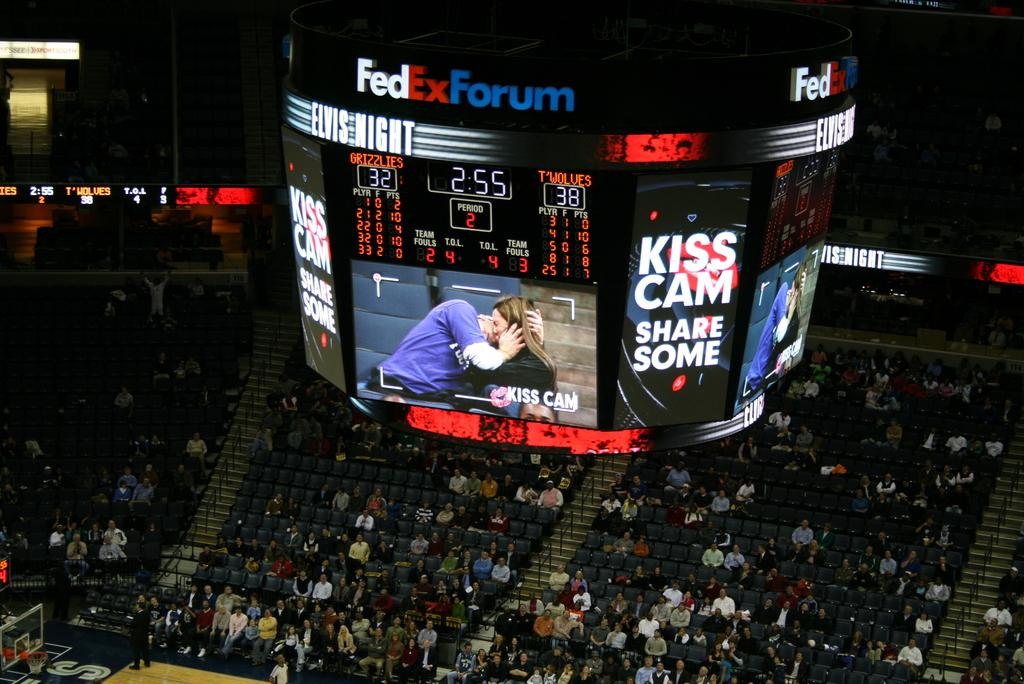<image>
Render a clear and concise summary of the photo. The scoreboard at FedEx Forum shows that the score is Minnesota Timberwolves 38, Memphis Grizzlies 32. 